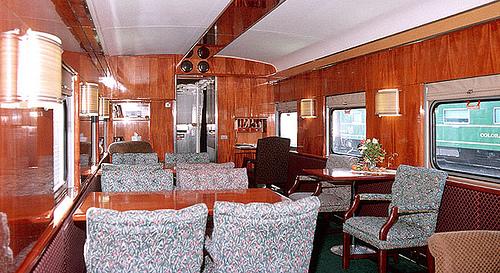Is the train stopped?
Concise answer only. Yes. Is there a train visible from the windows on the right side of the picture?
Quick response, please. Yes. Is this room mostly made out of wood?
Write a very short answer. Yes. 